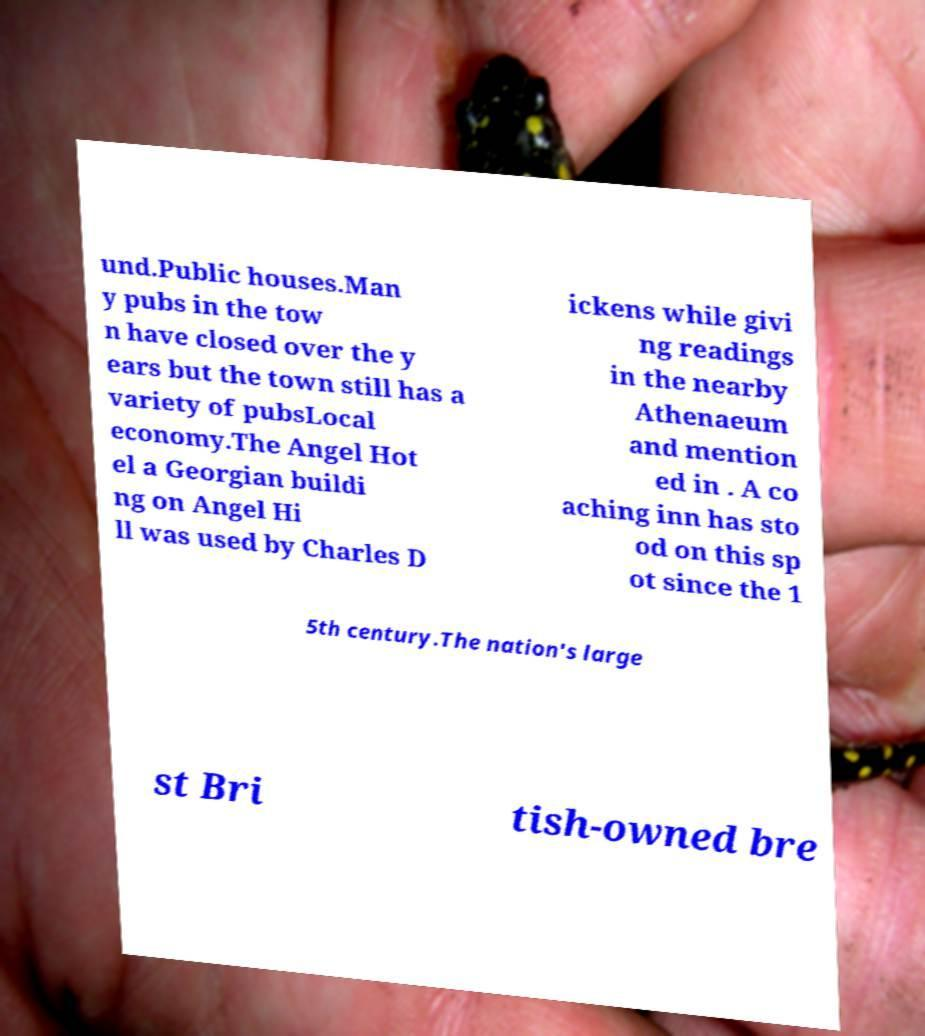There's text embedded in this image that I need extracted. Can you transcribe it verbatim? und.Public houses.Man y pubs in the tow n have closed over the y ears but the town still has a variety of pubsLocal economy.The Angel Hot el a Georgian buildi ng on Angel Hi ll was used by Charles D ickens while givi ng readings in the nearby Athenaeum and mention ed in . A co aching inn has sto od on this sp ot since the 1 5th century.The nation's large st Bri tish-owned bre 